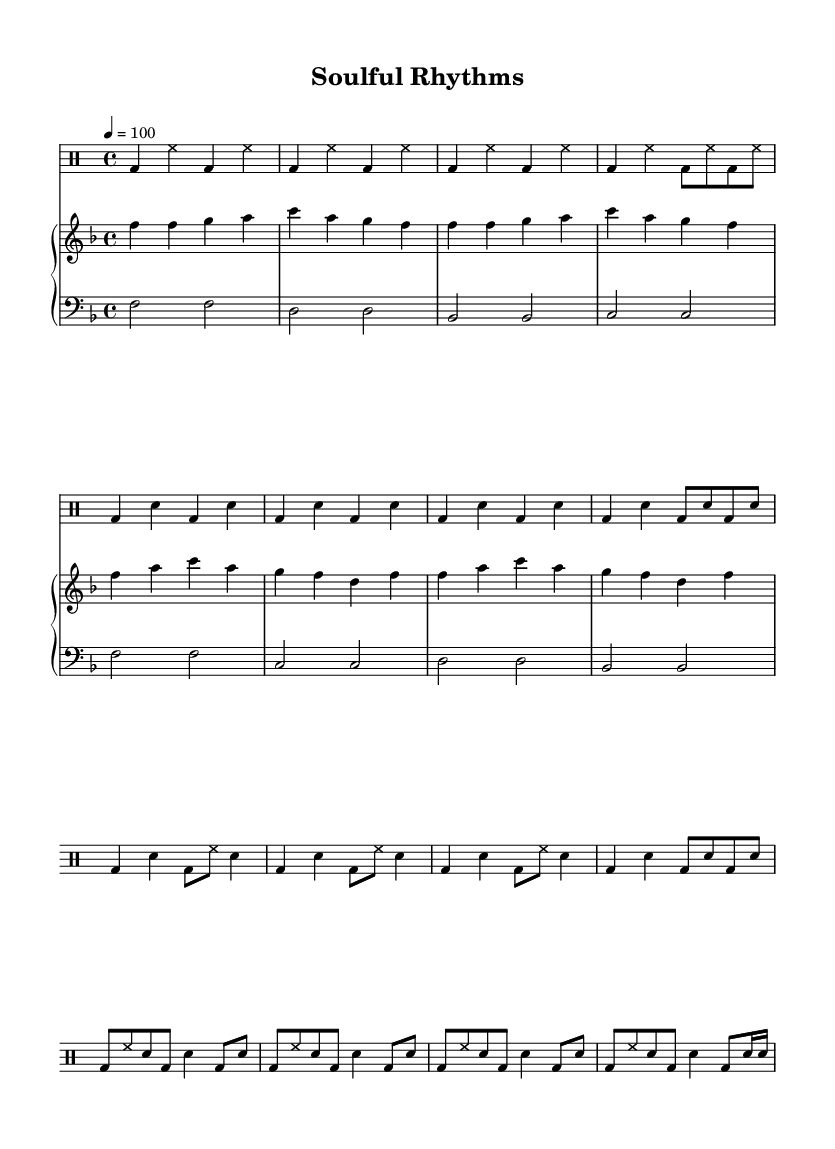What is the time signature of the piece? The time signature, indicated at the beginning of the score, is 4/4, which means there are four beats in each measure.
Answer: 4/4 What is the key signature of this music? The key signature is F major, which has one flat (B flat), as indicated at the beginning of the staff.
Answer: F major What is the tempo marking for this piece? The tempo marking is 4 = 100, indicating that there should be 100 quarter note beats per minute.
Answer: 100 How many times is the drum intro repeated? The drum intro is indicated to be repeated three times as shown by the repeat sign and the count preceding it.
Answer: 3 What is the rhythmic pattern used in the chorus? The rhythmic pattern in the chorus consists of a combination of bass drum and snare drum hits arranged in a 4/4 time signature, featuring a syncopated feel distinctive to R&B.
Answer: bass and snare Explain the difference in drum patterns between the verse and the bridge. In the verse, the drums have a straight quarter note pattern alternating between the bass drum and snare drum; however, in the bridge, the pattern becomes more intricate with eighth notes and a focus on syncopation, adding complexity.
Answer: Verse: simple; Bridge: intricate What instruments are used in this piece? The piece features a Drum Staff for percussion and a Piano Staff with both treble and bass clefs, indicating the use of piano for melody and harmony.
Answer: Drums and piano 